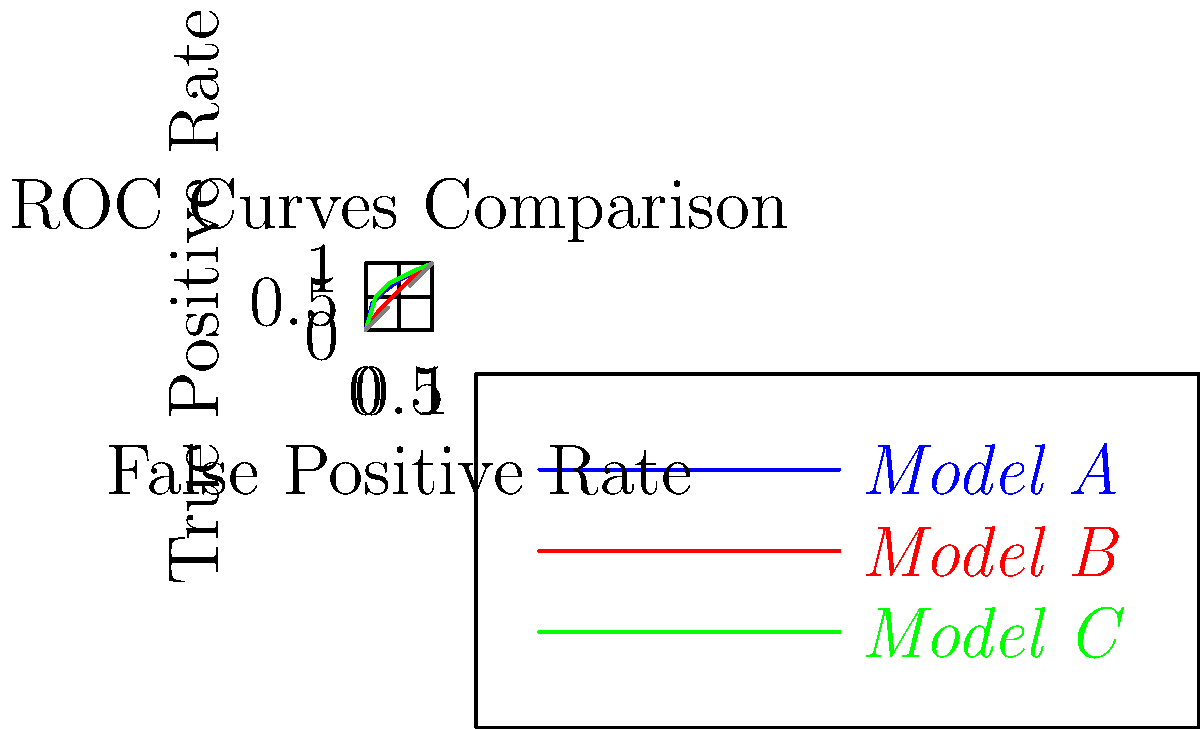As a programming enthusiast hosting live coding sessions, you're demonstrating ROC curve analysis for machine learning models. Given the ROC curves for three different models (A, B, and C) shown in the graph, which model demonstrates the best overall performance, and why? To determine the best performing model based on ROC curves, we need to analyze the following steps:

1. Understand ROC curves:
   - ROC curves plot the True Positive Rate (TPR) against the False Positive Rate (FPR) at various classification thresholds.
   - The closer the curve follows the top-left corner, the better the model's performance.

2. Compare Area Under the Curve (AUC):
   - AUC is a measure of the overall performance of a classifier.
   - A larger AUC indicates better performance.

3. Analyze each model:
   - Model A (blue): Curve is closest to the top-left corner for most of its length.
   - Model B (red): Curve is generally below Model A and Model C.
   - Model C (green): Curve is between Model A and Model B, closer to Model A.

4. Consider the trade-off between TPR and FPR:
   - Model A achieves higher TPR at lower FPR compared to other models.
   - Model B generally has lower TPR for given FPR values.
   - Model C performs well but is slightly outperformed by Model A.

5. Conclusion:
   - Model A demonstrates the best overall performance as its ROC curve is closest to the top-left corner, indicating a better balance between TPR and FPR across various thresholds.
Answer: Model A, due to its ROC curve being closest to the top-left corner, indicating the highest AUC and best balance between TPR and FPR. 